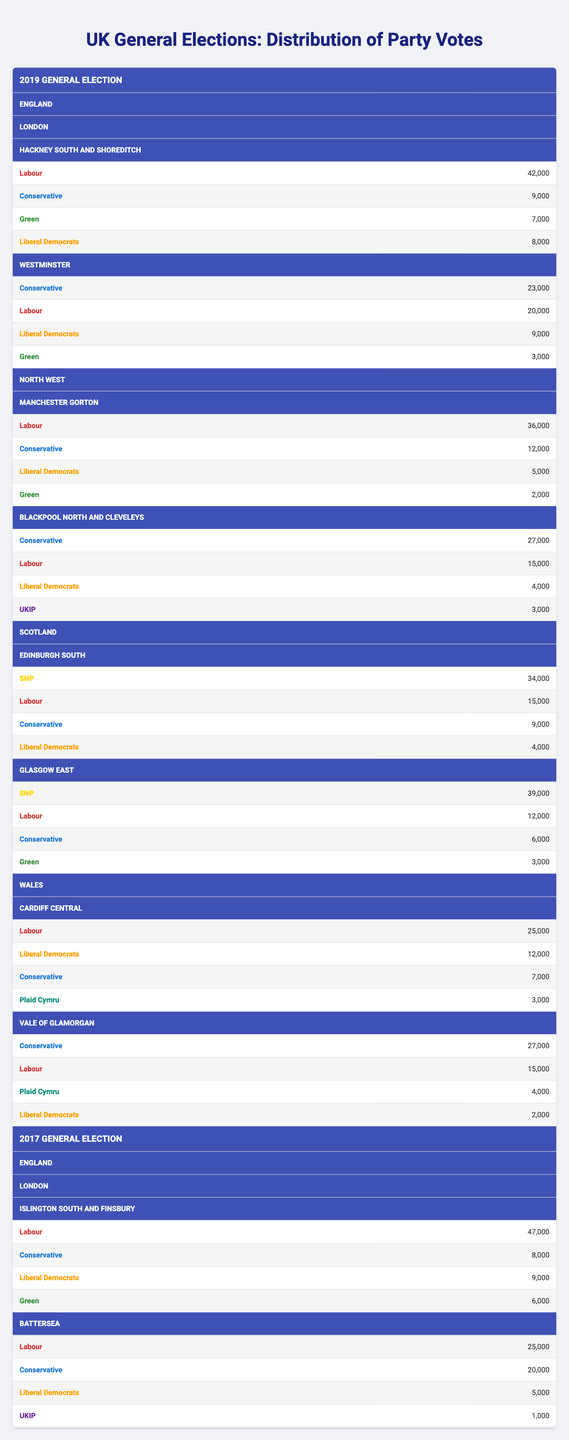What was the total number of votes for the Labour Party in Hackney South and Shoreditch in 2019? The table indicates that in Hackney South and Shoreditch, the Labour Party received 42,000 votes. Therefore, the total number of votes for Labour in this constituency for the year 2019 is 42,000.
Answer: 42,000 Which party received the least number of votes in Westminster in 2019? Looking at the party votes for Westminster, the party with the least votes is the Green Party, with 3,000 votes. Therefore, the least votes in Westminster in 2019 were for the Green Party.
Answer: Green What is the sum of votes for the Conservative Party across all constituencies in London in 2019? In London, the Conservative Party received 9,000 votes in Hackney South and Shoreditch and 23,000 votes in Westminster. Summing these gives 9,000 + 23,000 = 32,000. Thus, the total number of votes for the Conservative Party in London is 32,000.
Answer: 32,000 Is it true that the SNP received more votes than Labour in Glasgow East in 2019? In Glasgow East, the SNP received 39,000 votes while Labour received 12,000 votes. Since 39,000 is greater than 12,000, it is true that the SNP received more votes than Labour in this constituency.
Answer: Yes Which party had the highest number of votes in the Vale of Glamorgan in 2019, and how many votes did they receive? In Vale of Glamorgan, the Conservative Party received 27,000 votes, while Labour received 15,000 votes. As 27,000 is the highest of these numbers, the Conservative Party had the highest votes, receiving 27,000 votes.
Answer: Conservative, 27,000 What is the average number of votes for the Conservative Party across all constituencies in Scotland for 2019? The Conservative Party received 9,000 votes in Edinburgh South and 6,000 votes in Glasgow East. The average is calculated by taking the sum of these votes (9,000 + 6,000 = 15,000) and dividing by the number of constituencies (2), which gives 15,000 / 2 = 7,500. Therefore, the average number of votes for the Conservative Party in Scotland is 7,500.
Answer: 7,500 Which party received the highest number of votes overall in the Manchester Gorton constituency in 2019? The table shows that in Manchester Gorton, Labour received 36,000 votes, while the Conservative Party received 12,000 votes, the Liberal Democrats received 5,000 votes, and the Green Party received 2,000 votes. The highest among these is Labour with 36,000 votes.
Answer: Labour In the 2017 General Election, did any constituency in London have more than 45,000 votes for the Labour Party? The data indicates that Islington South and Finsbury had 47,000 votes for Labour, which is indeed more than 45,000. Therefore, it is true that at least one constituency had more than 45,000 votes for Labour in the 2017 General Election.
Answer: Yes 